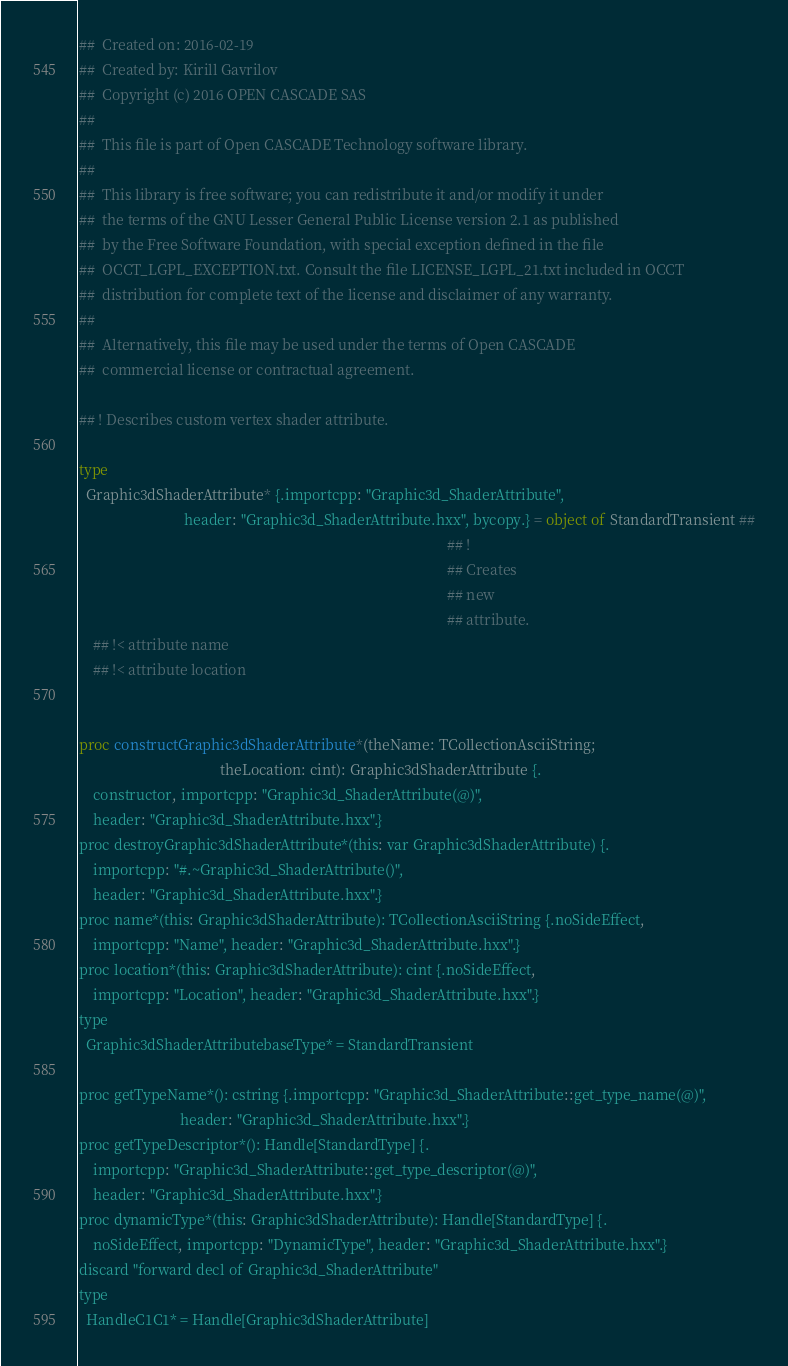Convert code to text. <code><loc_0><loc_0><loc_500><loc_500><_Nim_>##  Created on: 2016-02-19
##  Created by: Kirill Gavrilov
##  Copyright (c) 2016 OPEN CASCADE SAS
##
##  This file is part of Open CASCADE Technology software library.
##
##  This library is free software; you can redistribute it and/or modify it under
##  the terms of the GNU Lesser General Public License version 2.1 as published
##  by the Free Software Foundation, with special exception defined in the file
##  OCCT_LGPL_EXCEPTION.txt. Consult the file LICENSE_LGPL_21.txt included in OCCT
##  distribution for complete text of the license and disclaimer of any warranty.
##
##  Alternatively, this file may be used under the terms of Open CASCADE
##  commercial license or contractual agreement.

## ! Describes custom vertex shader attribute.

type
  Graphic3dShaderAttribute* {.importcpp: "Graphic3d_ShaderAttribute",
                             header: "Graphic3d_ShaderAttribute.hxx", bycopy.} = object of StandardTransient ##
                                                                                                      ## !
                                                                                                      ## Creates
                                                                                                      ## new
                                                                                                      ## attribute.
    ## !< attribute name
    ## !< attribute location


proc constructGraphic3dShaderAttribute*(theName: TCollectionAsciiString;
                                       theLocation: cint): Graphic3dShaderAttribute {.
    constructor, importcpp: "Graphic3d_ShaderAttribute(@)",
    header: "Graphic3d_ShaderAttribute.hxx".}
proc destroyGraphic3dShaderAttribute*(this: var Graphic3dShaderAttribute) {.
    importcpp: "#.~Graphic3d_ShaderAttribute()",
    header: "Graphic3d_ShaderAttribute.hxx".}
proc name*(this: Graphic3dShaderAttribute): TCollectionAsciiString {.noSideEffect,
    importcpp: "Name", header: "Graphic3d_ShaderAttribute.hxx".}
proc location*(this: Graphic3dShaderAttribute): cint {.noSideEffect,
    importcpp: "Location", header: "Graphic3d_ShaderAttribute.hxx".}
type
  Graphic3dShaderAttributebaseType* = StandardTransient

proc getTypeName*(): cstring {.importcpp: "Graphic3d_ShaderAttribute::get_type_name(@)",
                            header: "Graphic3d_ShaderAttribute.hxx".}
proc getTypeDescriptor*(): Handle[StandardType] {.
    importcpp: "Graphic3d_ShaderAttribute::get_type_descriptor(@)",
    header: "Graphic3d_ShaderAttribute.hxx".}
proc dynamicType*(this: Graphic3dShaderAttribute): Handle[StandardType] {.
    noSideEffect, importcpp: "DynamicType", header: "Graphic3d_ShaderAttribute.hxx".}
discard "forward decl of Graphic3d_ShaderAttribute"
type
  HandleC1C1* = Handle[Graphic3dShaderAttribute]


























</code> 